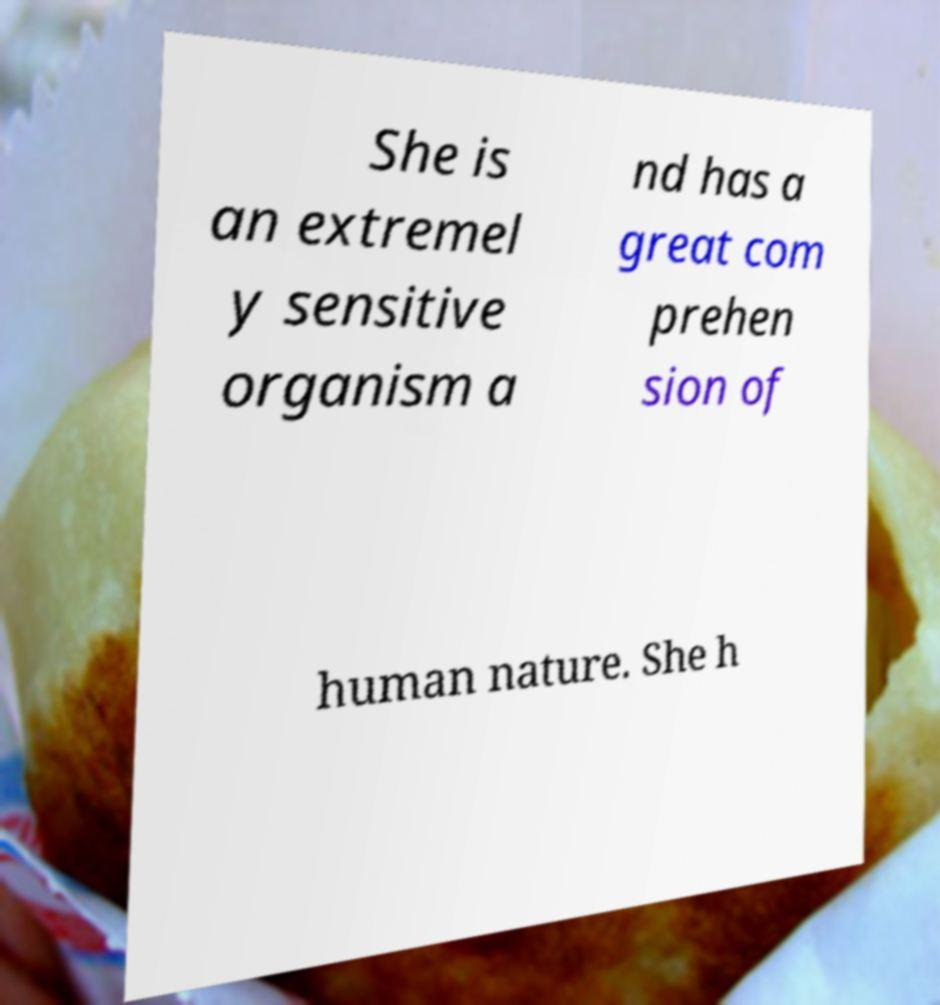Can you accurately transcribe the text from the provided image for me? She is an extremel y sensitive organism a nd has a great com prehen sion of human nature. She h 